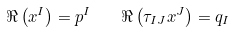<formula> <loc_0><loc_0><loc_500><loc_500>\Re \left ( x ^ { I } \right ) = p ^ { I } \quad \Re \left ( \tau _ { I J } x ^ { J } \right ) = q _ { I }</formula> 